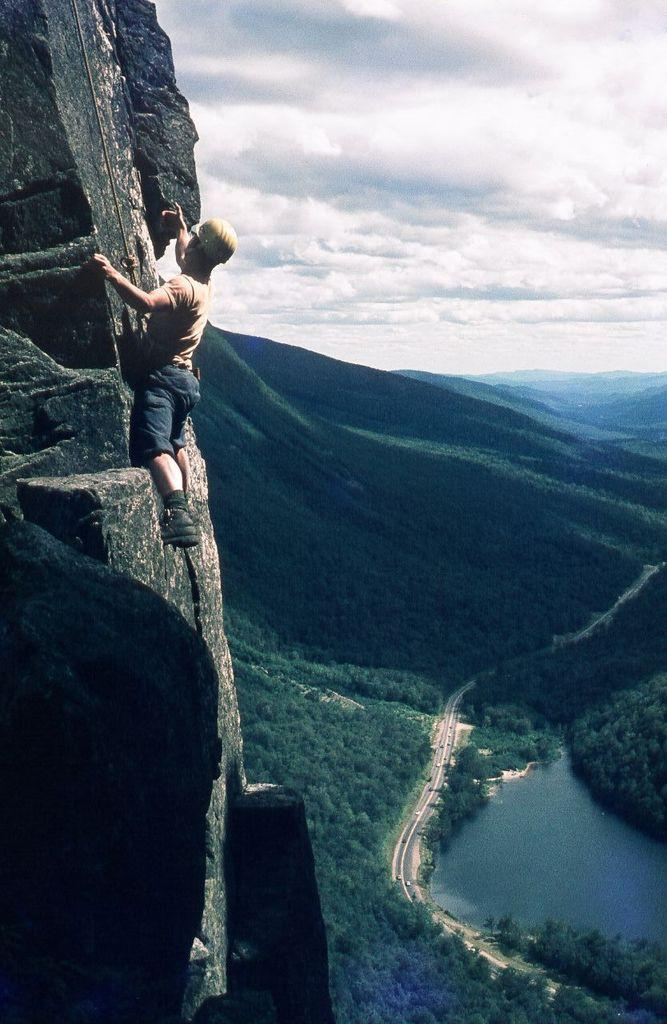What activity is the person on the left side of the image engaged in? The person is climbing a mountain on the left side of the image. What type of landscape can be seen in the image? There are hills, trees, and water visible in the image. What infrastructure is present in the image? There are roads and vehicles in the image. Where is the umbrella placed in the image? There is no umbrella present in the image. Can you describe the frog's habitat in the image? There is no frog present in the image. 